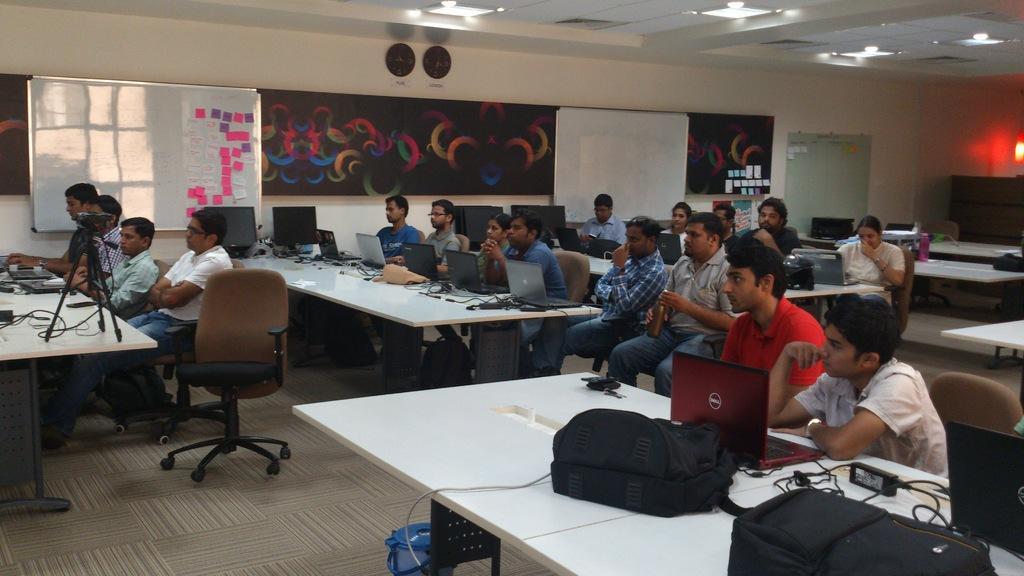How would you summarize this image in a sentence or two? A picture of a room. Every person is sitting on a chair. In-front of them there are tables, on table there laptops, cables and bags. On wall there are different type of boards. On this board there is a notes. On wall there are 2 clocks. On this table there is a camera. This is bin. 